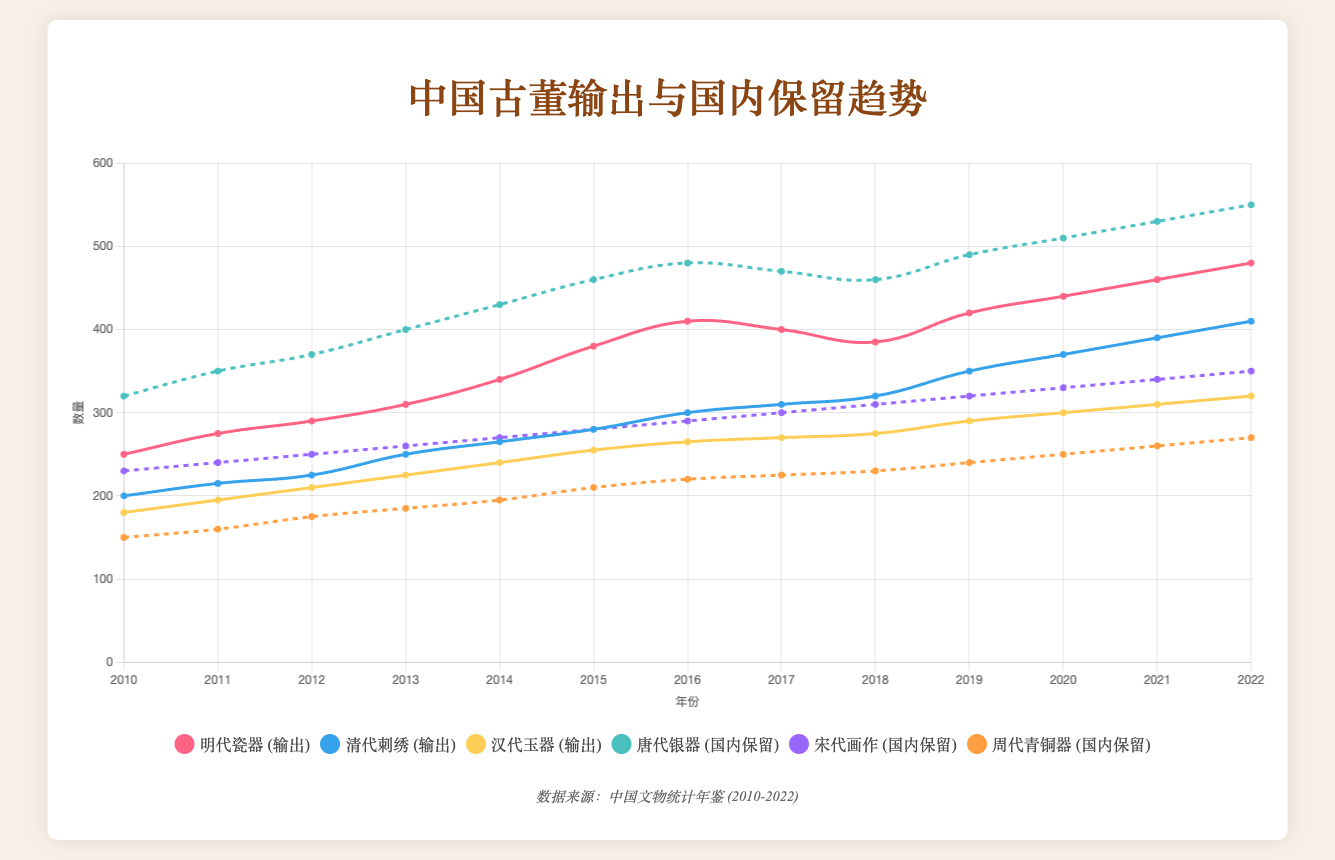What is the total number of exported Ming Dynasty Porcelain in 2015 and 2016? The value for 2015 is 380 and for 2016 is 410. Summing them up gives 380 + 410 = 790
Answer: 790 Which antiquity had the highest number of exports in 2022? In 2022, the values for exported Ming Dynasty Porcelain, Qing Dynasty Embroidery, and Han Dynasty Jade are 480, 410, and 320 respectively. The highest is Ming Dynasty Porcelain with 480 exports
Answer: Ming Dynasty Porcelain Which domestically retained antiquity shows the most consistent growth from 2010 to 2022? Look at the trend lines for Tang Dynasty Silverware, Song Dynasty Paintings, and Zhou Dynasty Bronzes. Song Dynasty Paintings and Zhou Dynasty Bronzes show consistent increases, but Song Dynasty Paintings has a steadier slope over the years
Answer: Song Dynasty Paintings What is the difference in the number of exported Ming Dynasty Porcelain between 2018 and 2019? The value for 2018 is 385 and for 2019 is 420. The difference is 420 - 385 = 35
Answer: 35 Which year saw the highest increase in the number of domestically retained Tang Dynasty Silverwares compared to the previous year? Examine the changes year-by-year. From 2018 to 2019, the increase is the most significant, from 460 to 490, which is 490 - 460 = 30
Answer: 2019 In 2020, did the domestically retained Zhou Dynasty Bronzes exceed the exported Han Dynasty Jade? The value for Zhou Dynasty Bronzes is 250, and for Han Dynasty Jade is 300. 250 < 300, thus Zhou Dynasty Bronzes did not exceed
Answer: No What is the overall trend of Qing Dynasty Embroidery exports from 2010 to 2022? Observe the line for Qing Dynasty Embroidery from 2010 (200) to 2022 (410). The overall trend shows an increase in the number of exports
Answer: Increasing Compare the number of domestically retained Song Dynasty Paintings and Zhou Dynasty Bronzes in 2016. Which is higher? The value for Song Dynasty Paintings in 2016 is 290 and for Zhou Dynasty Bronzes is 220. 290 > 220, so Song Dynasty Paintings is higher
Answer: Song Dynasty Paintings 